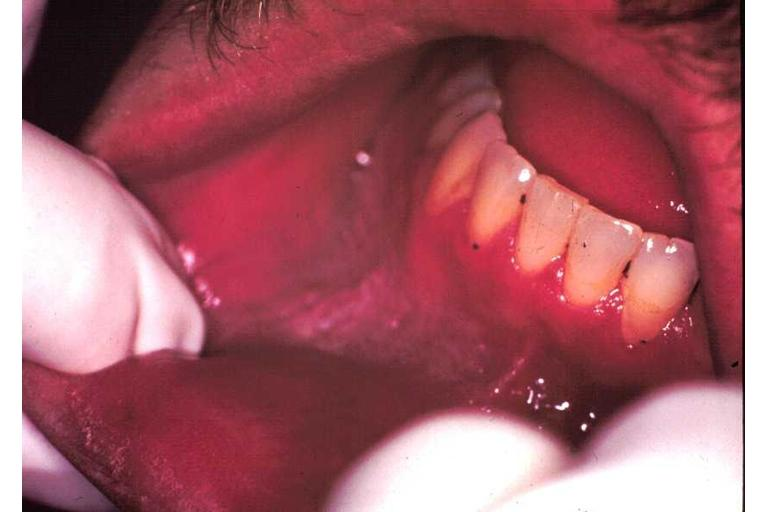does hyperplasia median bar show leukoplakia?
Answer the question using a single word or phrase. No 